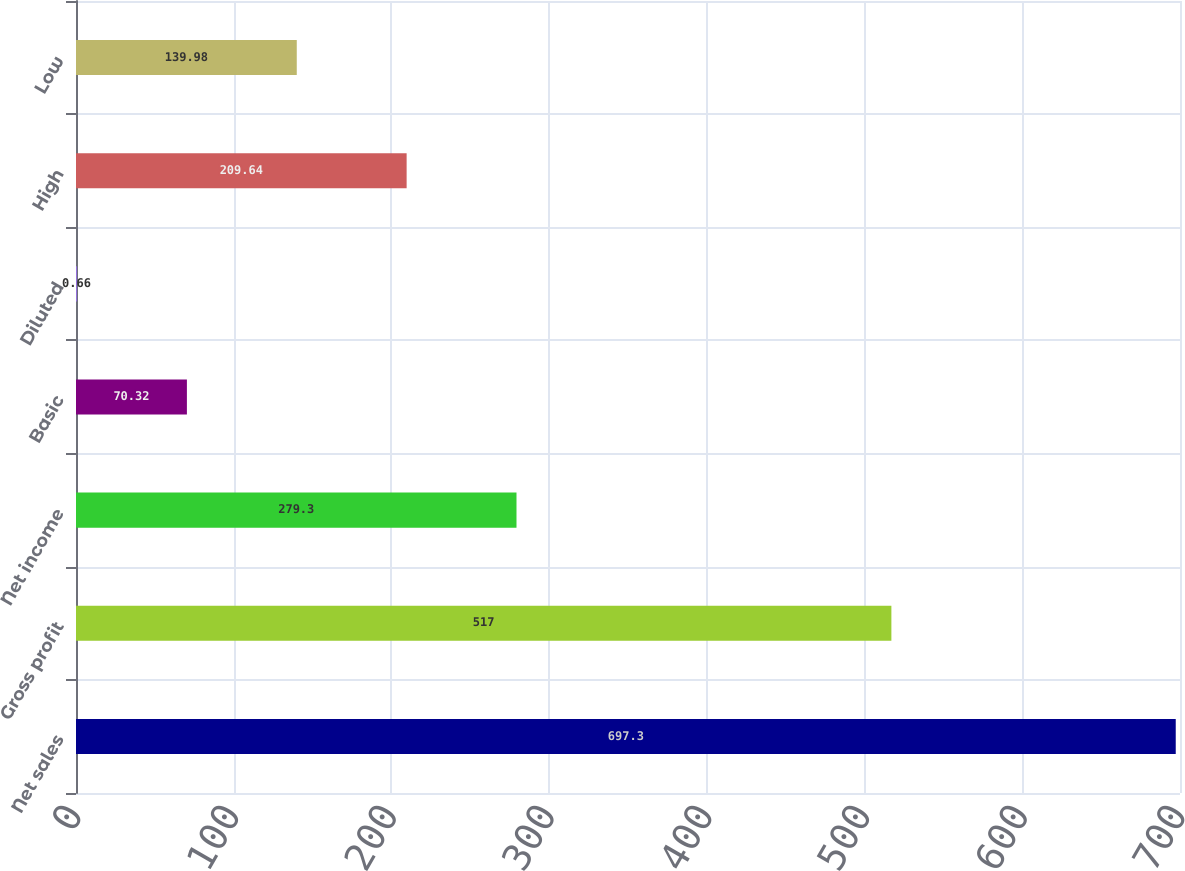Convert chart. <chart><loc_0><loc_0><loc_500><loc_500><bar_chart><fcel>Net sales<fcel>Gross profit<fcel>Net income<fcel>Basic<fcel>Diluted<fcel>High<fcel>Low<nl><fcel>697.3<fcel>517<fcel>279.3<fcel>70.32<fcel>0.66<fcel>209.64<fcel>139.98<nl></chart> 